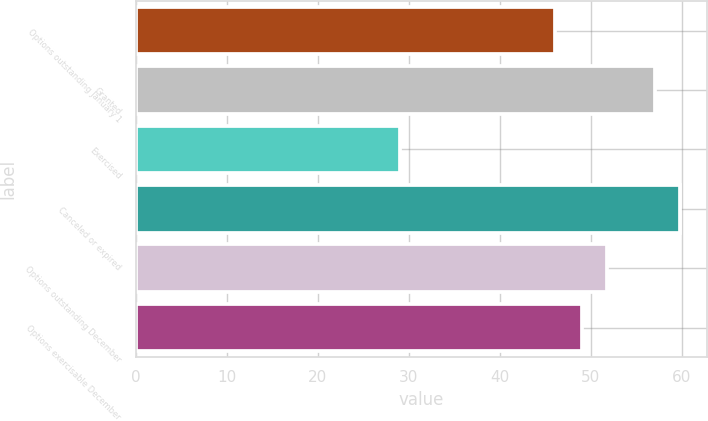Convert chart. <chart><loc_0><loc_0><loc_500><loc_500><bar_chart><fcel>Options outstanding January 1<fcel>Granted<fcel>Exercised<fcel>Canceled or expired<fcel>Options outstanding December<fcel>Options exercisable December<nl><fcel>46<fcel>57<fcel>29<fcel>59.8<fcel>51.8<fcel>49<nl></chart> 